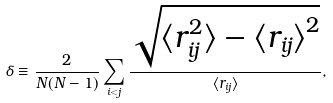<formula> <loc_0><loc_0><loc_500><loc_500>\delta \equiv \frac { 2 } { N ( N - 1 ) } \sum _ { i < j } \frac { \sqrt { { \langle r _ { i j } ^ { 2 } \rangle } - { \langle r _ { i j } \rangle } ^ { 2 } } } { \langle r _ { i j } \rangle } ,</formula> 